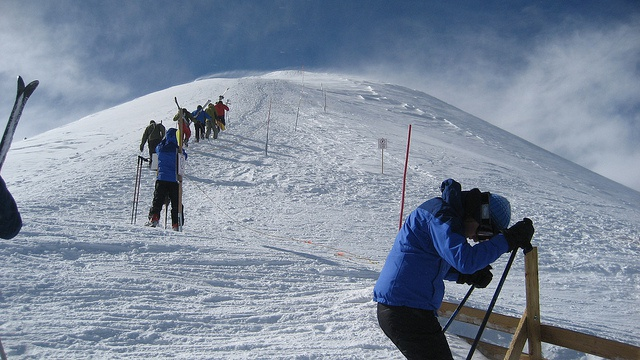Describe the objects in this image and their specific colors. I can see people in gray, black, navy, and blue tones, people in gray, black, navy, and darkblue tones, people in gray, black, navy, and darkgray tones, people in gray, black, and lightgray tones, and people in gray, black, and darkgray tones in this image. 